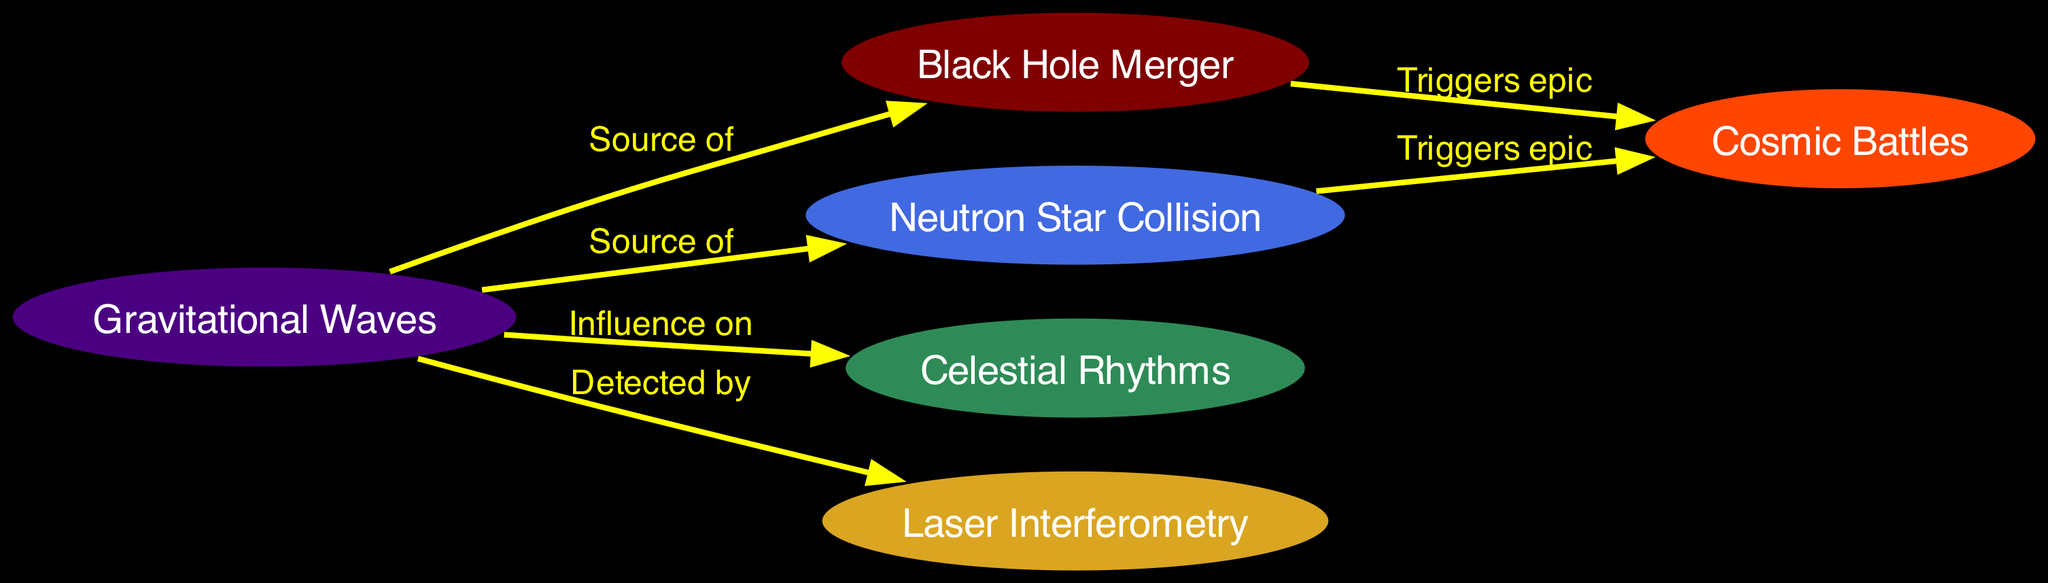What is the main subject represented in the diagram? The main subject of the diagram is gravitational waves, which are represented by the node that is labeled "Gravitational Waves." This node is central and connects with multiple other nodes, indicating it is the primary focus.
Answer: Gravitational Waves How many nodes are there in the diagram? To determine the number of nodes, we can simply count each distinct labeled item in the diagram. The total is six unique nodes.
Answer: 6 What triggers cosmic battles according to the diagram? The edges leading from "Black Hole Merger" and "Neutron Star Collision" both point to "Cosmic Battles" with the label "Triggers epic." Therefore, both phenomena trigger cosmic battles as represented in the diagram.
Answer: Black Hole Merger, Neutron Star Collision What does "Gravitational Waves" influence in the diagram? The edge connecting "Gravitational Waves" to "Celestial Rhythms" indicates the influence of gravitational waves, as denoted by the label "Influence on." Thus, gravitational waves influence celestial rhythms.
Answer: Celestial Rhythms What technique is used to detect gravitational waves? The edge from "Gravitational Waves" to "Laser Interferometry" with the label "Detected by" reveals that laser interferometry is the technique employed for this purpose.
Answer: Laser Interferometry Which two types of cosmic events are sources of gravitational waves? The nodes "Black Hole Merger" and "Neutron Star Collision" both direct edges labeled "Source of" towards the "Gravitational Waves" node. This indicates that both types of events are sources of gravitational waves.
Answer: Black Hole Merger, Neutron Star Collision How do black hole mergers and neutron star collisions relate to cosmic battles? Both "Black Hole Merger" and "Neutron Star Collision" have edges labeled "Triggers epic" that connect to "Cosmic Battles." This means both types of mergers are crucial in instigating cosmic battles.
Answer: Triggers epic What color represents the "Cosmic Battles" node? By looking at the diagram's color coding for nodes, the "Cosmic Battles" node is identified by the color orange red.
Answer: Orange Red 